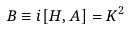Convert formula to latex. <formula><loc_0><loc_0><loc_500><loc_500>B \equiv i [ H , A ] = K ^ { 2 }</formula> 